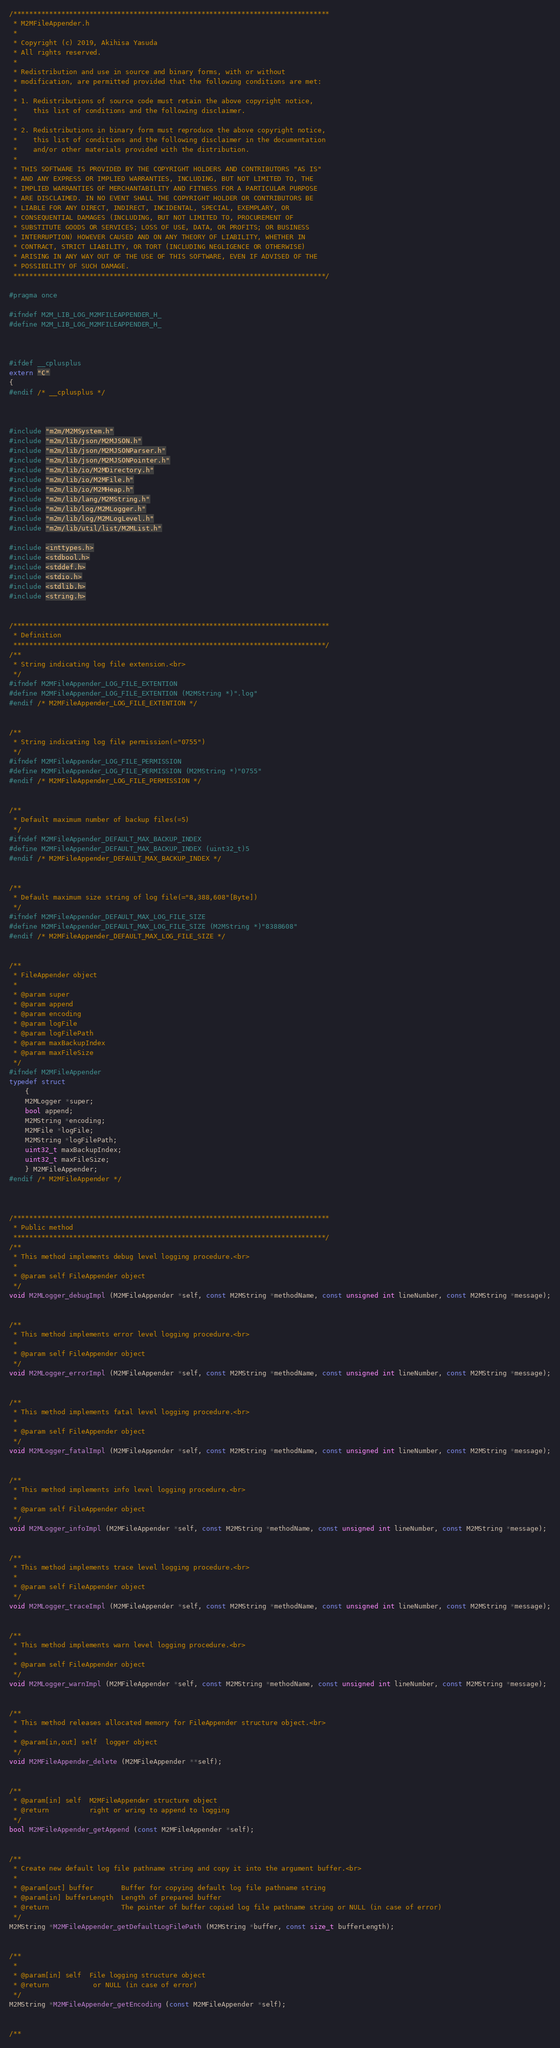Convert code to text. <code><loc_0><loc_0><loc_500><loc_500><_C_>/*******************************************************************************
 * M2MFileAppender.h
 *
 * Copyright (c) 2019, Akihisa Yasuda
 * All rights reserved.
 *
 * Redistribution and use in source and binary forms, with or without
 * modification, are permitted provided that the following conditions are met:
 *
 * 1. Redistributions of source code must retain the above copyright notice,
 *    this list of conditions and the following disclaimer.
 *
 * 2. Redistributions in binary form must reproduce the above copyright notice,
 *    this list of conditions and the following disclaimer in the documentation
 *    and/or other materials provided with the distribution.
 *
 * THIS SOFTWARE IS PROVIDED BY THE COPYRIGHT HOLDERS AND CONTRIBUTORS "AS IS"
 * AND ANY EXPRESS OR IMPLIED WARRANTIES, INCLUDING, BUT NOT LIMITED TO, THE
 * IMPLIED WARRANTIES OF MERCHANTABILITY AND FITNESS FOR A PARTICULAR PURPOSE
 * ARE DISCLAIMED. IN NO EVENT SHALL THE COPYRIGHT HOLDER OR CONTRIBUTORS BE
 * LIABLE FOR ANY DIRECT, INDIRECT, INCIDENTAL, SPECIAL, EXEMPLARY, OR
 * CONSEQUENTIAL DAMAGES (INCLUDING, BUT NOT LIMITED TO, PROCUREMENT OF
 * SUBSTITUTE GOODS OR SERVICES; LOSS OF USE, DATA, OR PROFITS; OR BUSINESS
 * INTERRUPTION) HOWEVER CAUSED AND ON ANY THEORY OF LIABILITY, WHETHER IN
 * CONTRACT, STRICT LIABILITY, OR TORT (INCLUDING NEGLIGENCE OR OTHERWISE)
 * ARISING IN ANY WAY OUT OF THE USE OF THIS SOFTWARE, EVEN IF ADVISED OF THE
 * POSSIBILITY OF SUCH DAMAGE.
 ******************************************************************************/

#pragma once

#ifndef M2M_LIB_LOG_M2MFILEAPPENDER_H_
#define M2M_LIB_LOG_M2MFILEAPPENDER_H_



#ifdef __cplusplus
extern "C"
{
#endif /* __cplusplus */



#include "m2m/M2MSystem.h"
#include "m2m/lib/json/M2MJSON.h"
#include "m2m/lib/json/M2MJSONParser.h"
#include "m2m/lib/json/M2MJSONPointer.h"
#include "m2m/lib/io/M2MDirectory.h"
#include "m2m/lib/io/M2MFile.h"
#include "m2m/lib/io/M2MHeap.h"
#include "m2m/lib/lang/M2MString.h"
#include "m2m/lib/log/M2MLogger.h"
#include "m2m/lib/log/M2MLogLevel.h"
#include "m2m/lib/util/list/M2MList.h"

#include <inttypes.h>
#include <stdbool.h>
#include <stddef.h>
#include <stdio.h>
#include <stdlib.h>
#include <string.h>


/*******************************************************************************
 * Definition
 ******************************************************************************/
/**
 * String indicating log file extension.<br>
 */
#ifndef M2MFileAppender_LOG_FILE_EXTENTION
#define M2MFileAppender_LOG_FILE_EXTENTION (M2MString *)".log"
#endif /* M2MFileAppender_LOG_FILE_EXTENTION */


/**
 * String indicating log file permission(="0755")
 */
#ifndef M2MFileAppender_LOG_FILE_PERMISSION
#define M2MFileAppender_LOG_FILE_PERMISSION (M2MString *)"0755"
#endif /* M2MFileAppender_LOG_FILE_PERMISSION */


/**
 * Default maximum number of backup files(=5)
 */
#ifndef M2MFileAppender_DEFAULT_MAX_BACKUP_INDEX
#define M2MFileAppender_DEFAULT_MAX_BACKUP_INDEX (uint32_t)5
#endif /* M2MFileAppender_DEFAULT_MAX_BACKUP_INDEX */


/**
 * Default maximum size string of log file(="8,388,608"[Byte])
 */
#ifndef M2MFileAppender_DEFAULT_MAX_LOG_FILE_SIZE
#define M2MFileAppender_DEFAULT_MAX_LOG_FILE_SIZE (M2MString *)"8388608"
#endif /* M2MFileAppender_DEFAULT_MAX_LOG_FILE_SIZE */


/**
 * FileAppender object
 *
 * @param super
 * @param append
 * @param encoding
 * @param logFile
 * @param logFilePath
 * @param maxBackupIndex
 * @param maxFileSize
 */
#ifndef M2MFileAppender
typedef struct
	{
	M2MLogger *super;
	bool append;
	M2MString *encoding;
	M2MFile *logFile;
	M2MString *logFilePath;
	uint32_t maxBackupIndex;
	uint32_t maxFileSize;
	} M2MFileAppender;
#endif /* M2MFileAppender */



/*******************************************************************************
 * Public method
 ******************************************************************************/
/**
 * This method implements debug level logging procedure.<br>
 *
 * @param self FileAppender object
 */
void M2MLogger_debugImpl (M2MFileAppender *self, const M2MString *methodName, const unsigned int lineNumber, const M2MString *message);


/**
 * This method implements error level logging procedure.<br>
 *
 * @param self FileAppender object
 */
void M2MLogger_errorImpl (M2MFileAppender *self, const M2MString *methodName, const unsigned int lineNumber, const M2MString *message);


/**
 * This method implements fatal level logging procedure.<br>
 *
 * @param self FileAppender object
 */
void M2MLogger_fatalImpl (M2MFileAppender *self, const M2MString *methodName, const unsigned int lineNumber, const M2MString *message);


/**
 * This method implements info level logging procedure.<br>
 *
 * @param self FileAppender object
 */
void M2MLogger_infoImpl (M2MFileAppender *self, const M2MString *methodName, const unsigned int lineNumber, const M2MString *message);


/**
 * This method implements trace level logging procedure.<br>
 *
 * @param self FileAppender object
 */
void M2MLogger_traceImpl (M2MFileAppender *self, const M2MString *methodName, const unsigned int lineNumber, const M2MString *message);


/**
 * This method implements warn level logging procedure.<br>
 *
 * @param self FileAppender object
 */
void M2MLogger_warnImpl (M2MFileAppender *self, const M2MString *methodName, const unsigned int lineNumber, const M2MString *message);


/**
 * This method releases allocated memory for FileAppender structure object.<br>
 *
 * @param[in,out] self	logger object
 */
void M2MFileAppender_delete (M2MFileAppender **self);


/**
 * @param[in] self	M2MFileAppender structure object
 * @return			right or wring to append to logging
 */
bool M2MFileAppender_getAppend (const M2MFileAppender *self);


/**
 * Create new default log file pathname string and copy it into the argument buffer.<br>
 *
 * @param[out] buffer		Buffer for copying default log file pathname string
 * @param[in] bufferLength	Length of prepared buffer
 * @return					The pointer of buffer copied log file pathname string or NULL (in case of error)
 */
M2MString *M2MFileAppender_getDefaultLogFilePath (M2MString *buffer, const size_t bufferLength);


/**
 *
 * @param[in] self	File logging structure object
 * @return			 or NULL (in case of error)
 */
M2MString *M2MFileAppender_getEncoding (const M2MFileAppender *self);


/**</code> 